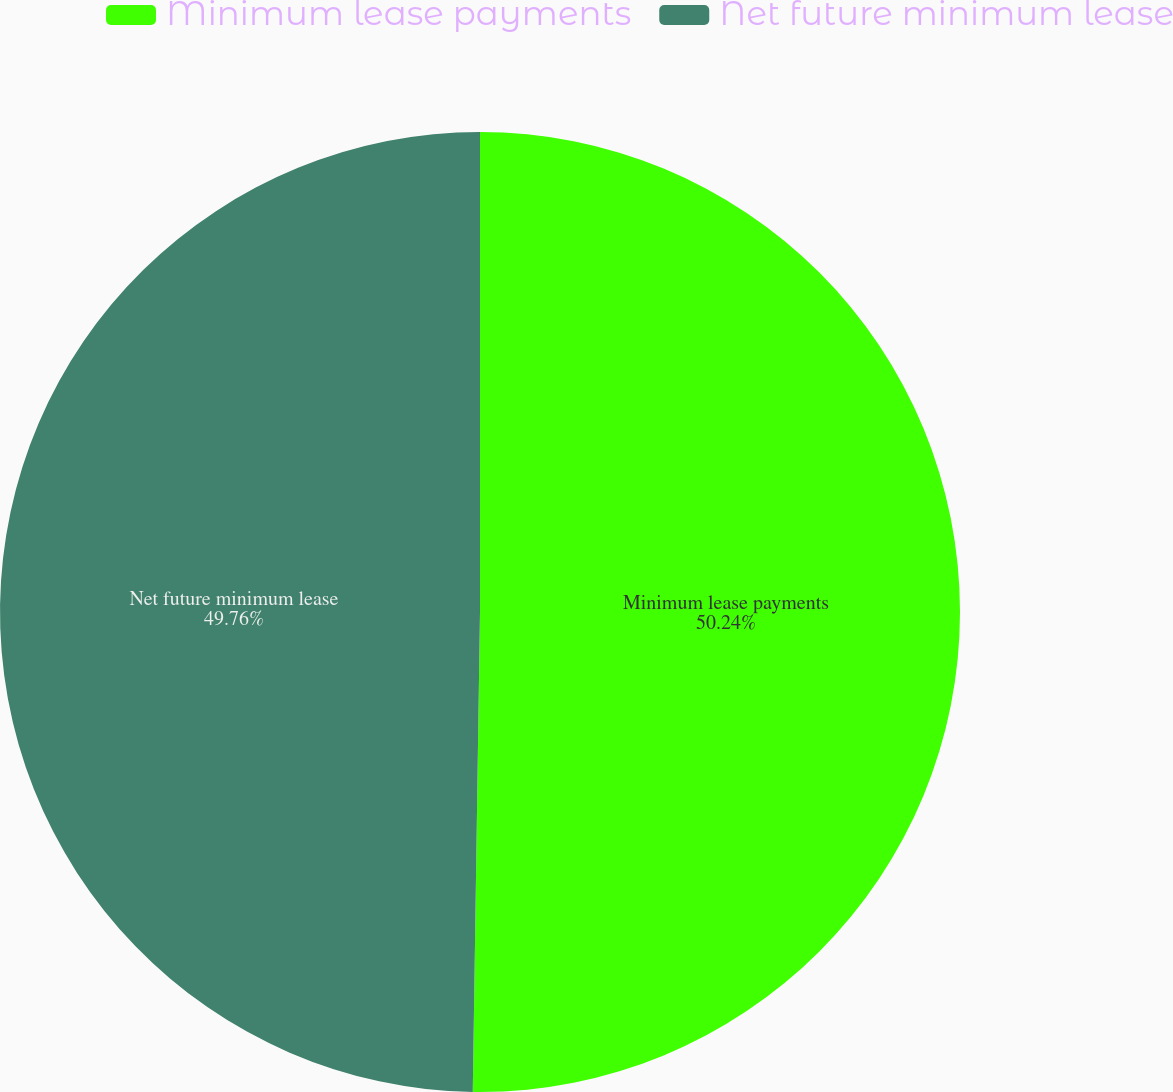Convert chart. <chart><loc_0><loc_0><loc_500><loc_500><pie_chart><fcel>Minimum lease payments<fcel>Net future minimum lease<nl><fcel>50.24%<fcel>49.76%<nl></chart> 